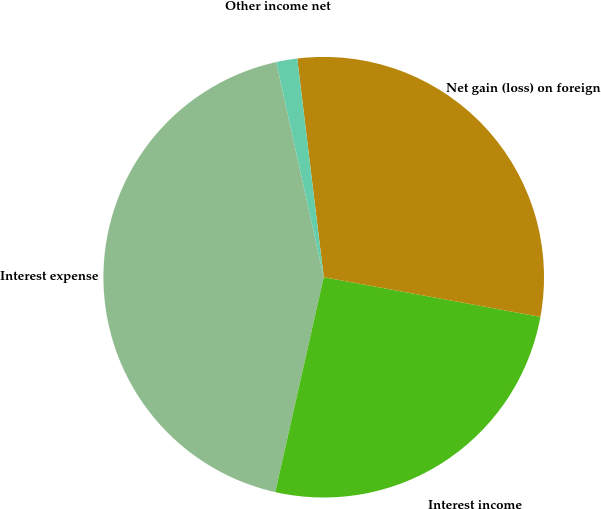Convert chart. <chart><loc_0><loc_0><loc_500><loc_500><pie_chart><fcel>Interest expense<fcel>Interest income<fcel>Net gain (loss) on foreign<fcel>Other income net<nl><fcel>43.01%<fcel>25.65%<fcel>29.8%<fcel>1.54%<nl></chart> 